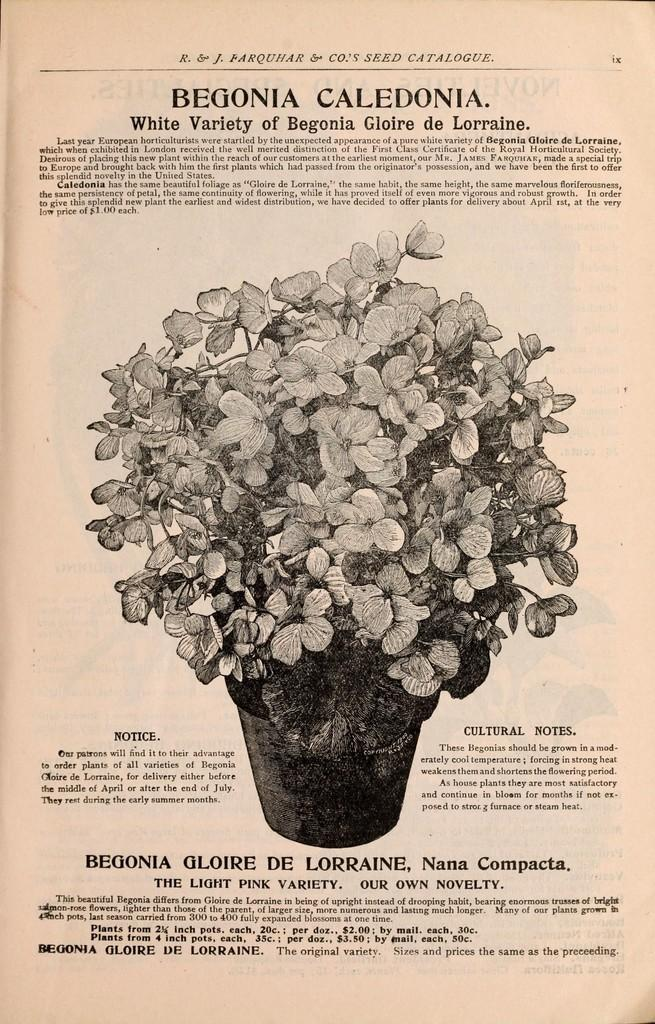What type of visual is the image? The image is a poster. What is shown in the poster? There is a depiction of a flower pot in the image. Are there any words on the poster? Yes, there is text on the image. What type of attraction is depicted in the image? There is no attraction depicted in the image; it features a flower pot and text. How many eggs are shown in the image? There are no eggs present in the image. 